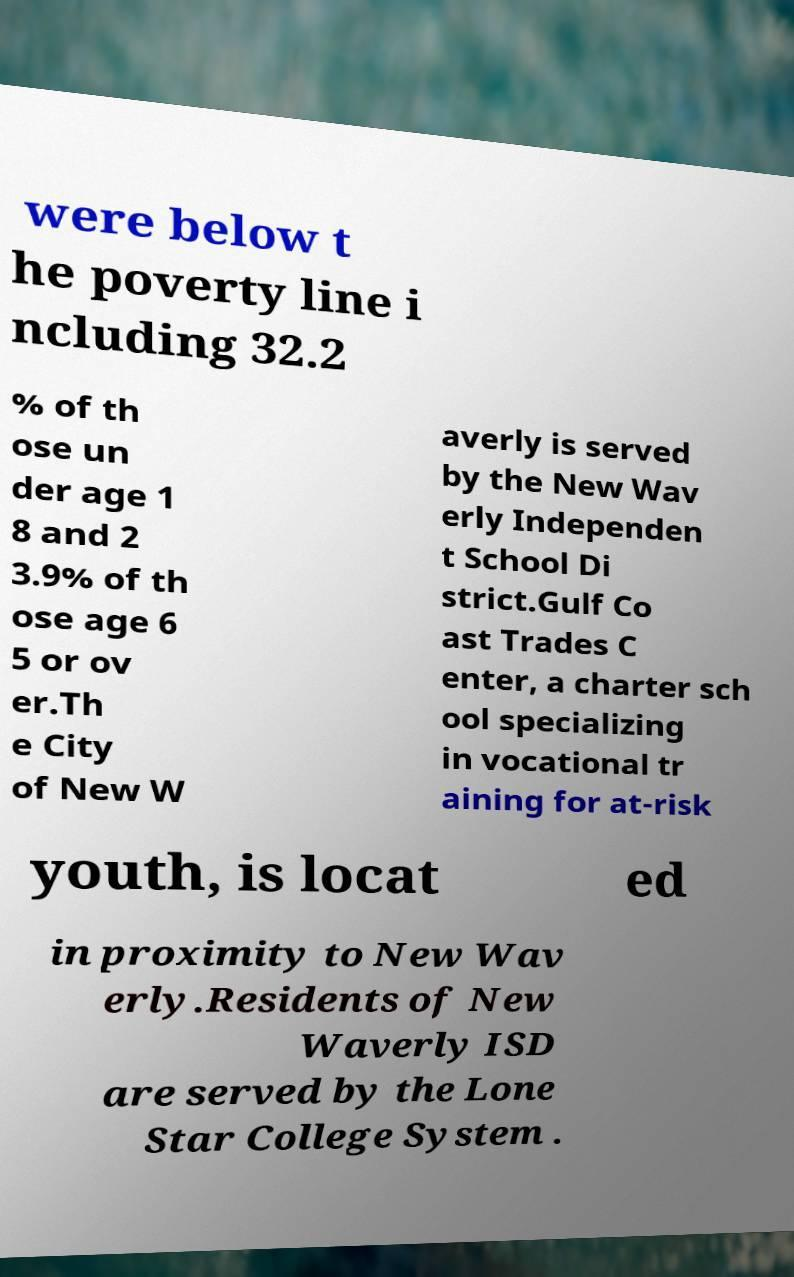For documentation purposes, I need the text within this image transcribed. Could you provide that? were below t he poverty line i ncluding 32.2 % of th ose un der age 1 8 and 2 3.9% of th ose age 6 5 or ov er.Th e City of New W averly is served by the New Wav erly Independen t School Di strict.Gulf Co ast Trades C enter, a charter sch ool specializing in vocational tr aining for at-risk youth, is locat ed in proximity to New Wav erly.Residents of New Waverly ISD are served by the Lone Star College System . 